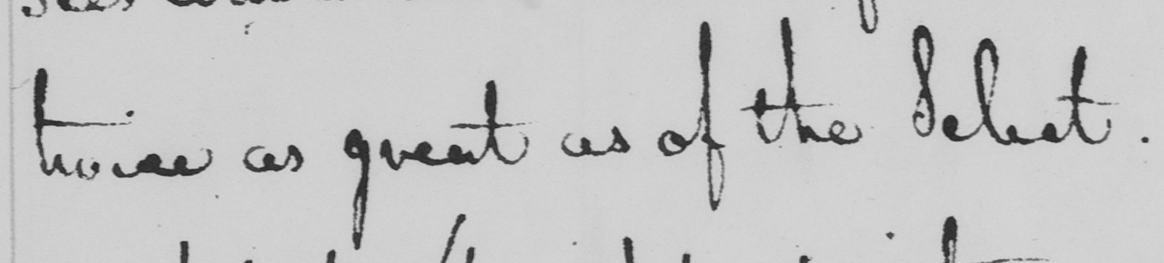Please provide the text content of this handwritten line. twice as great as of the Select . 